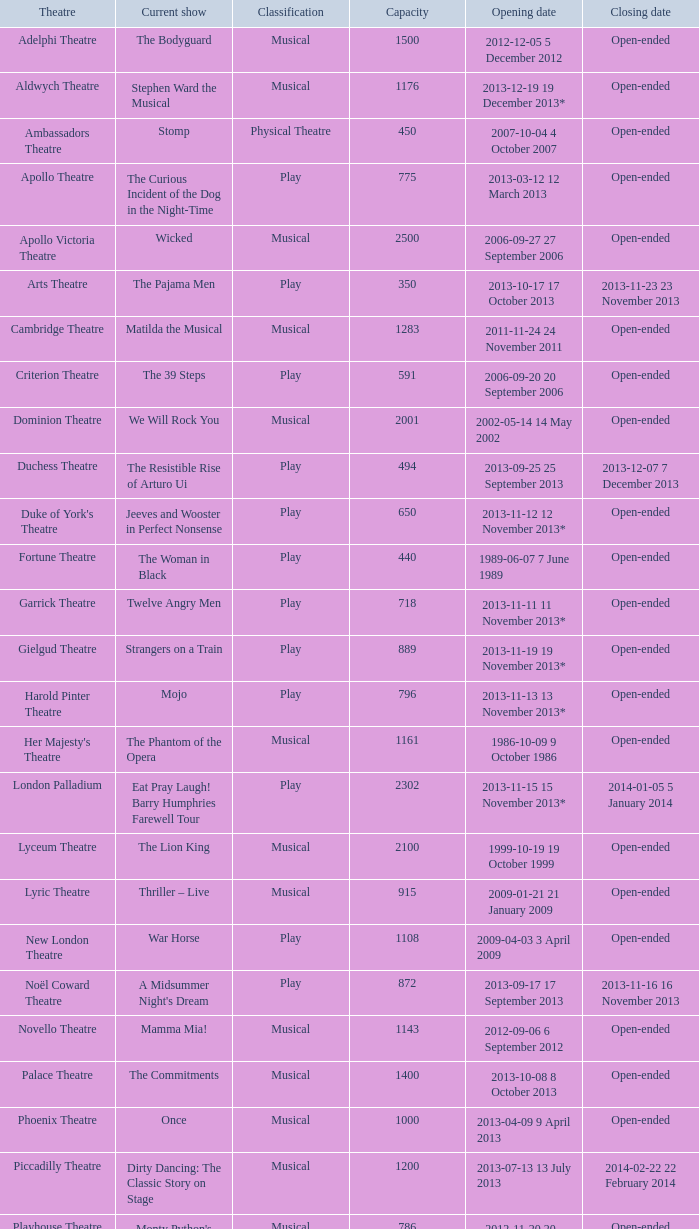What opening date has a capacity of 100? 2013-11-01 1 November 2013. 